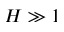<formula> <loc_0><loc_0><loc_500><loc_500>H \gg 1</formula> 